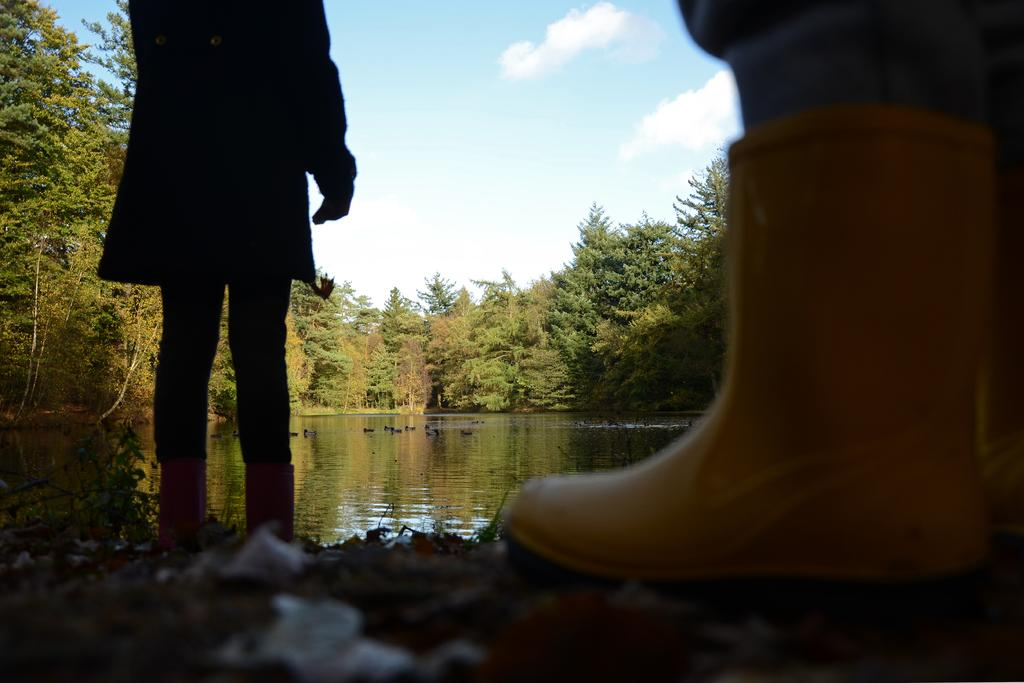What type of footwear is the person wearing in the image? The person is wearing yellow boots in the image. What is the person's posture in the image? The person is standing in the image. What can be seen in the foreground of the image? There is water visible in the image. What is visible in the background of the image? There are trees in the background of the image. What is visible at the top of the image? The sky is visible at the top of the image. What type of language is spoken by the person in the image? There is no information about the language spoken by the person in the image. How many pizzas are visible in the image? There are no pizzas present in the image. 